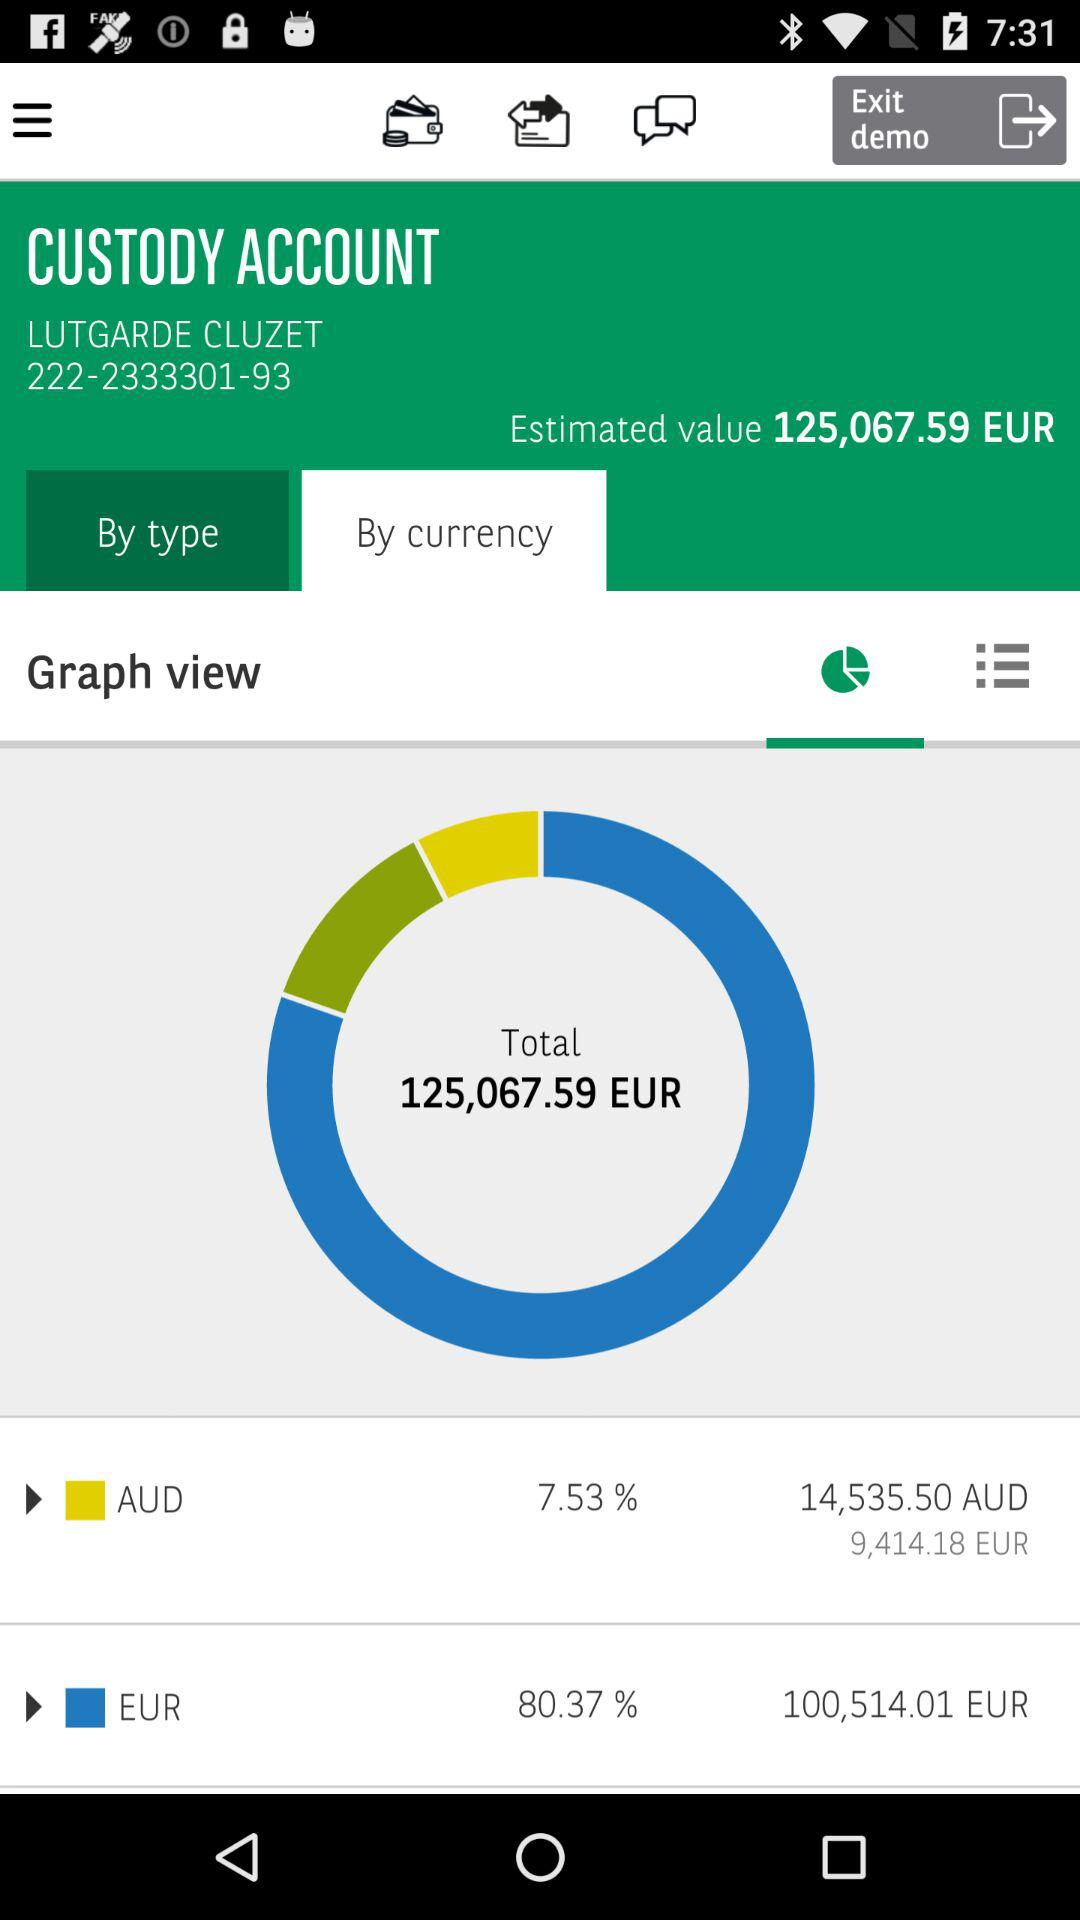What is the estimated value? The estimated value is 125,067.59 euros. 